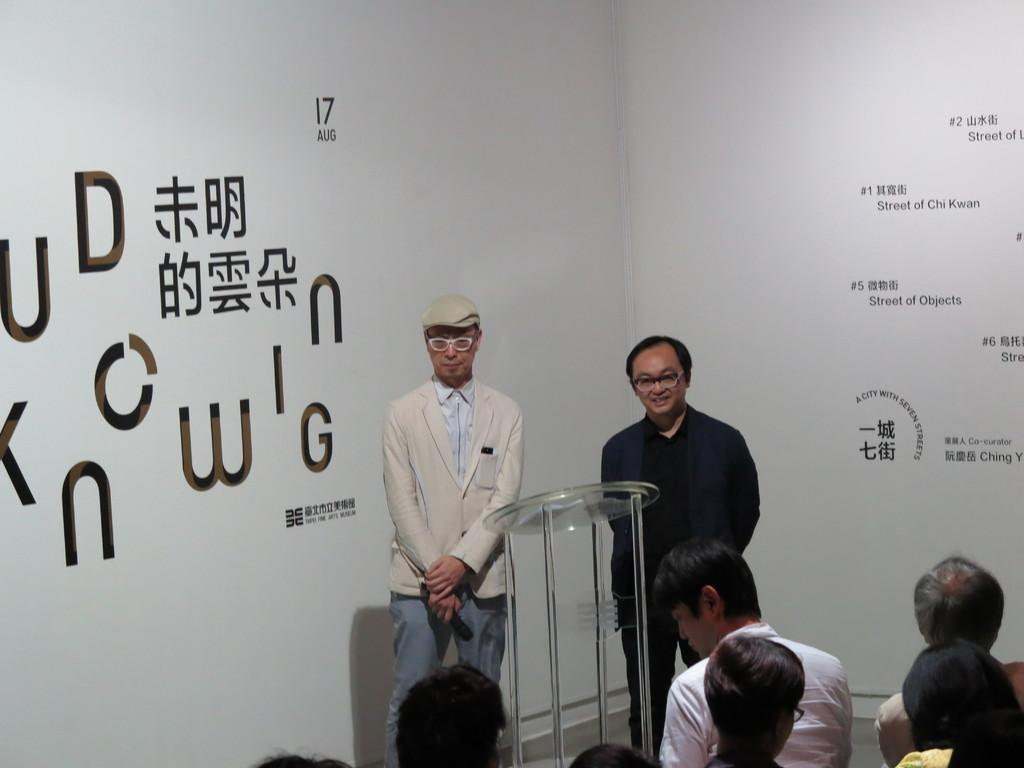What are the people in the image doing? The people in the image are sitting and talking to the opposite persons. What is placed between the people? There is a stand placed between the people. What type of curve can be seen on the playground in the image? There is no playground present in the image, so there is no curve to be seen. How comfortable are the people sitting in the image? The image does not provide information about the comfort level of the people sitting, so it cannot be determined from the image. 